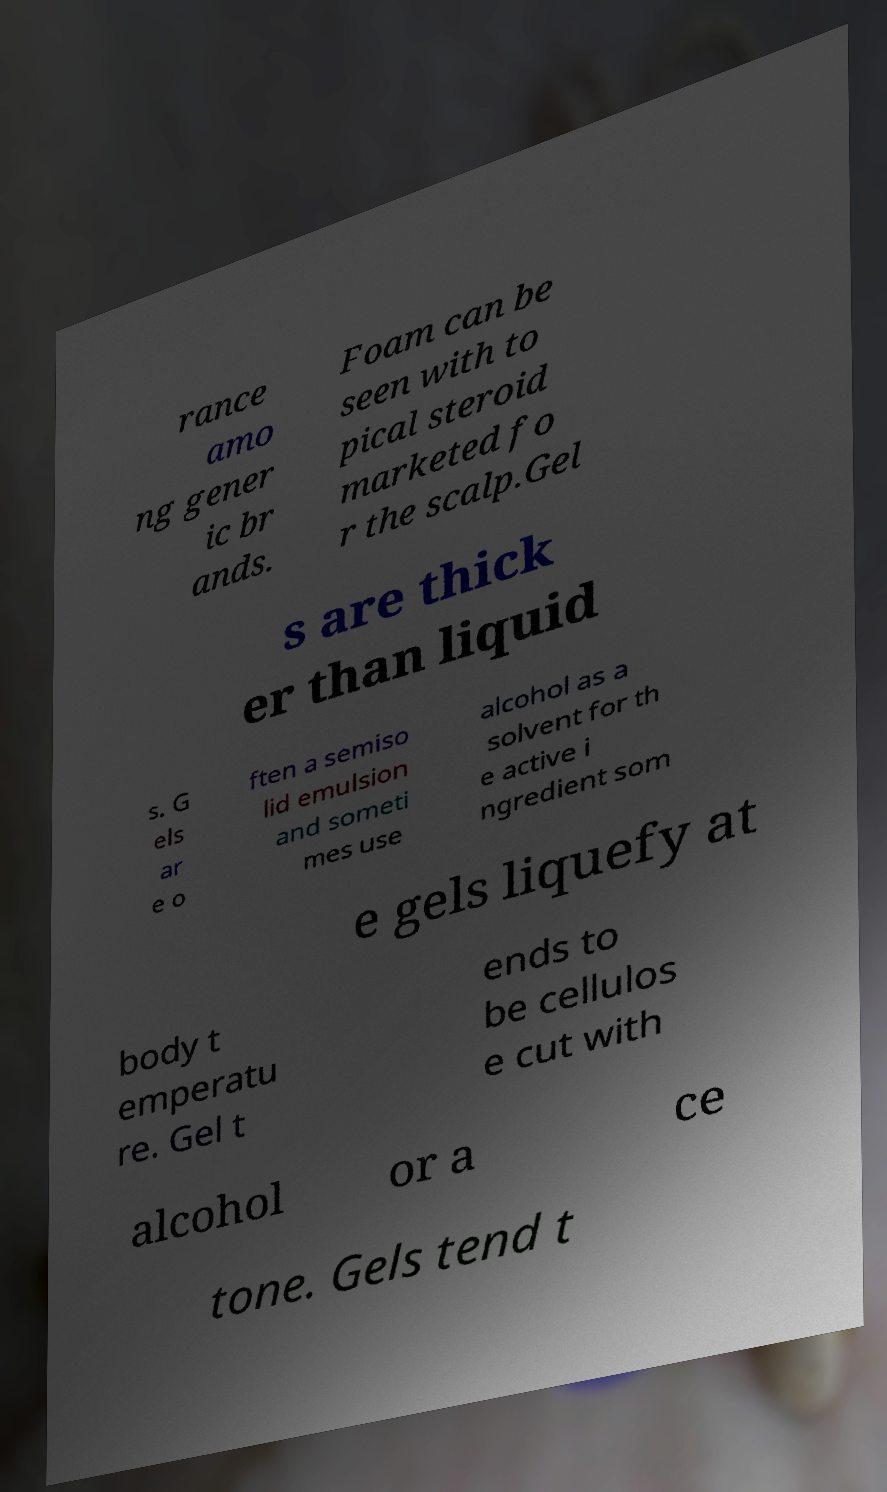There's text embedded in this image that I need extracted. Can you transcribe it verbatim? rance amo ng gener ic br ands. Foam can be seen with to pical steroid marketed fo r the scalp.Gel s are thick er than liquid s. G els ar e o ften a semiso lid emulsion and someti mes use alcohol as a solvent for th e active i ngredient som e gels liquefy at body t emperatu re. Gel t ends to be cellulos e cut with alcohol or a ce tone. Gels tend t 